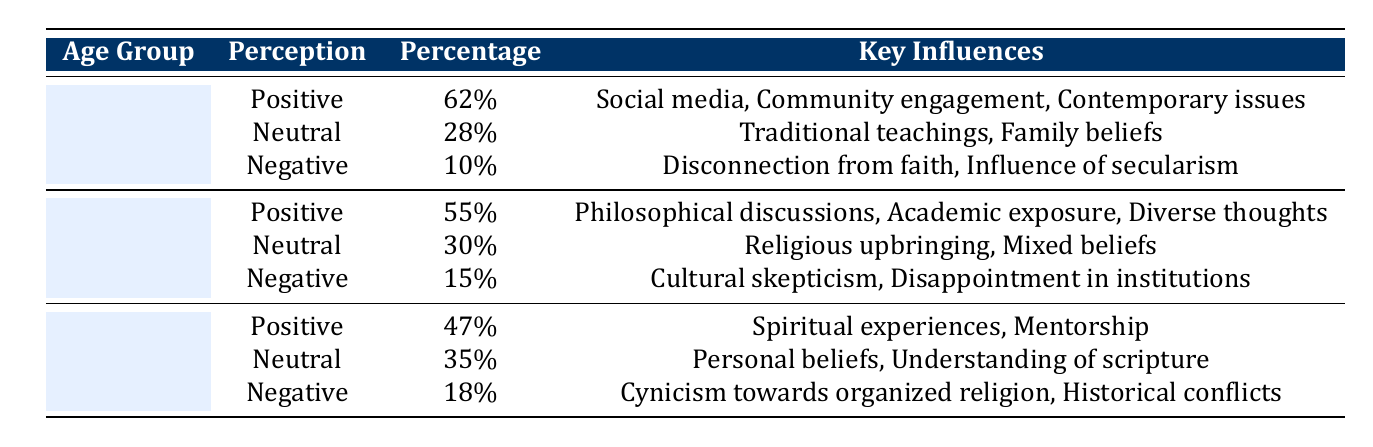What percentage of listeners aged 18-24 have a positive perception of modern theology? The table indicates that 62% of listeners aged 18-24 perceive modern theology positively, as stated in the "Positive" row for the "18-24" age group.
Answer: 62% What are the key influences for listeners aged 25-30 who have a negative perception of modern theology? For the "Negative" perception in the "25-30" age group, the key influences are listed as "Cultural skepticism" and "Disappointment in institutions".
Answer: Cultural skepticism, Disappointment in institutions Is the perception of modern theology among listeners aged 31-35 more positive than negative? In the "31-35" age group, 47% have a positive perception while 18% have a negative perception, making it evident that the positive perception exceeds the negative.
Answer: Yes What is the difference in the percentage of positive perceptions between the 18-24 and 25-30 age groups? The positive perception for the 18-24 age group is 62%, while for the 25-30 age group it is 55%. The difference is calculated as 62% - 55% = 7%.
Answer: 7% What percentage of listeners aged 31-35 have a neutral perception? The table shows that 35% of listeners in the 31-35 age group have a neutral perception of modern theology, as stated in the corresponding row for that age group.
Answer: 35% Are "Spiritual experiences" listed as a key influence for listeners aged 18-24? The table indicates that "Spiritual experiences" are key influences only for the "31-35" age group, and therefore they are not relevant for the 18-24 age group.
Answer: No What is the average percentage of positive perception across all age groups? For positive perceptions, we have 62% (18-24) + 55% (25-30) + 47% (31-35). Adding these gives: 62 + 55 + 47 = 164. Dividing by 3 gives the average of 164/3 = approximately 54.67%.
Answer: 54.67% How many listeners aged 25-30 perceive modern theology neutrally? According to the table, 30% of the 25-30 age group have a neutral perception, as can be seen in the "Neutral" row for that age group.
Answer: 30% Which age group has the highest percentage of negative perception? The negative perception percentages are 10% (18-24), 15% (25-30), and 18% (31-35). The highest percentage is 18% from the 31-35 age group.
Answer: 31-35 